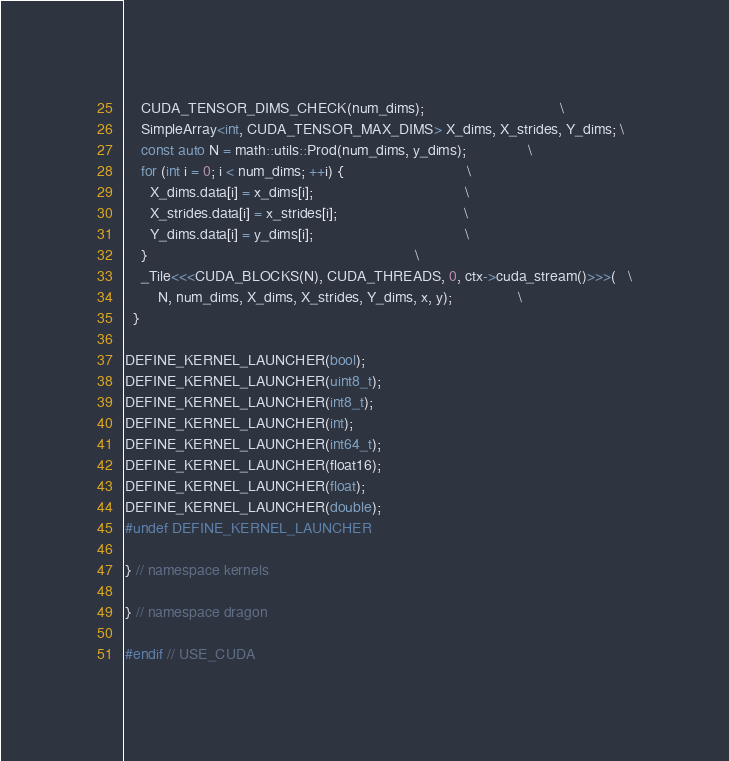<code> <loc_0><loc_0><loc_500><loc_500><_Cuda_>    CUDA_TENSOR_DIMS_CHECK(num_dims);                                 \
    SimpleArray<int, CUDA_TENSOR_MAX_DIMS> X_dims, X_strides, Y_dims; \
    const auto N = math::utils::Prod(num_dims, y_dims);               \
    for (int i = 0; i < num_dims; ++i) {                              \
      X_dims.data[i] = x_dims[i];                                     \
      X_strides.data[i] = x_strides[i];                               \
      Y_dims.data[i] = y_dims[i];                                     \
    }                                                                 \
    _Tile<<<CUDA_BLOCKS(N), CUDA_THREADS, 0, ctx->cuda_stream()>>>(   \
        N, num_dims, X_dims, X_strides, Y_dims, x, y);                \
  }

DEFINE_KERNEL_LAUNCHER(bool);
DEFINE_KERNEL_LAUNCHER(uint8_t);
DEFINE_KERNEL_LAUNCHER(int8_t);
DEFINE_KERNEL_LAUNCHER(int);
DEFINE_KERNEL_LAUNCHER(int64_t);
DEFINE_KERNEL_LAUNCHER(float16);
DEFINE_KERNEL_LAUNCHER(float);
DEFINE_KERNEL_LAUNCHER(double);
#undef DEFINE_KERNEL_LAUNCHER

} // namespace kernels

} // namespace dragon

#endif // USE_CUDA
</code> 